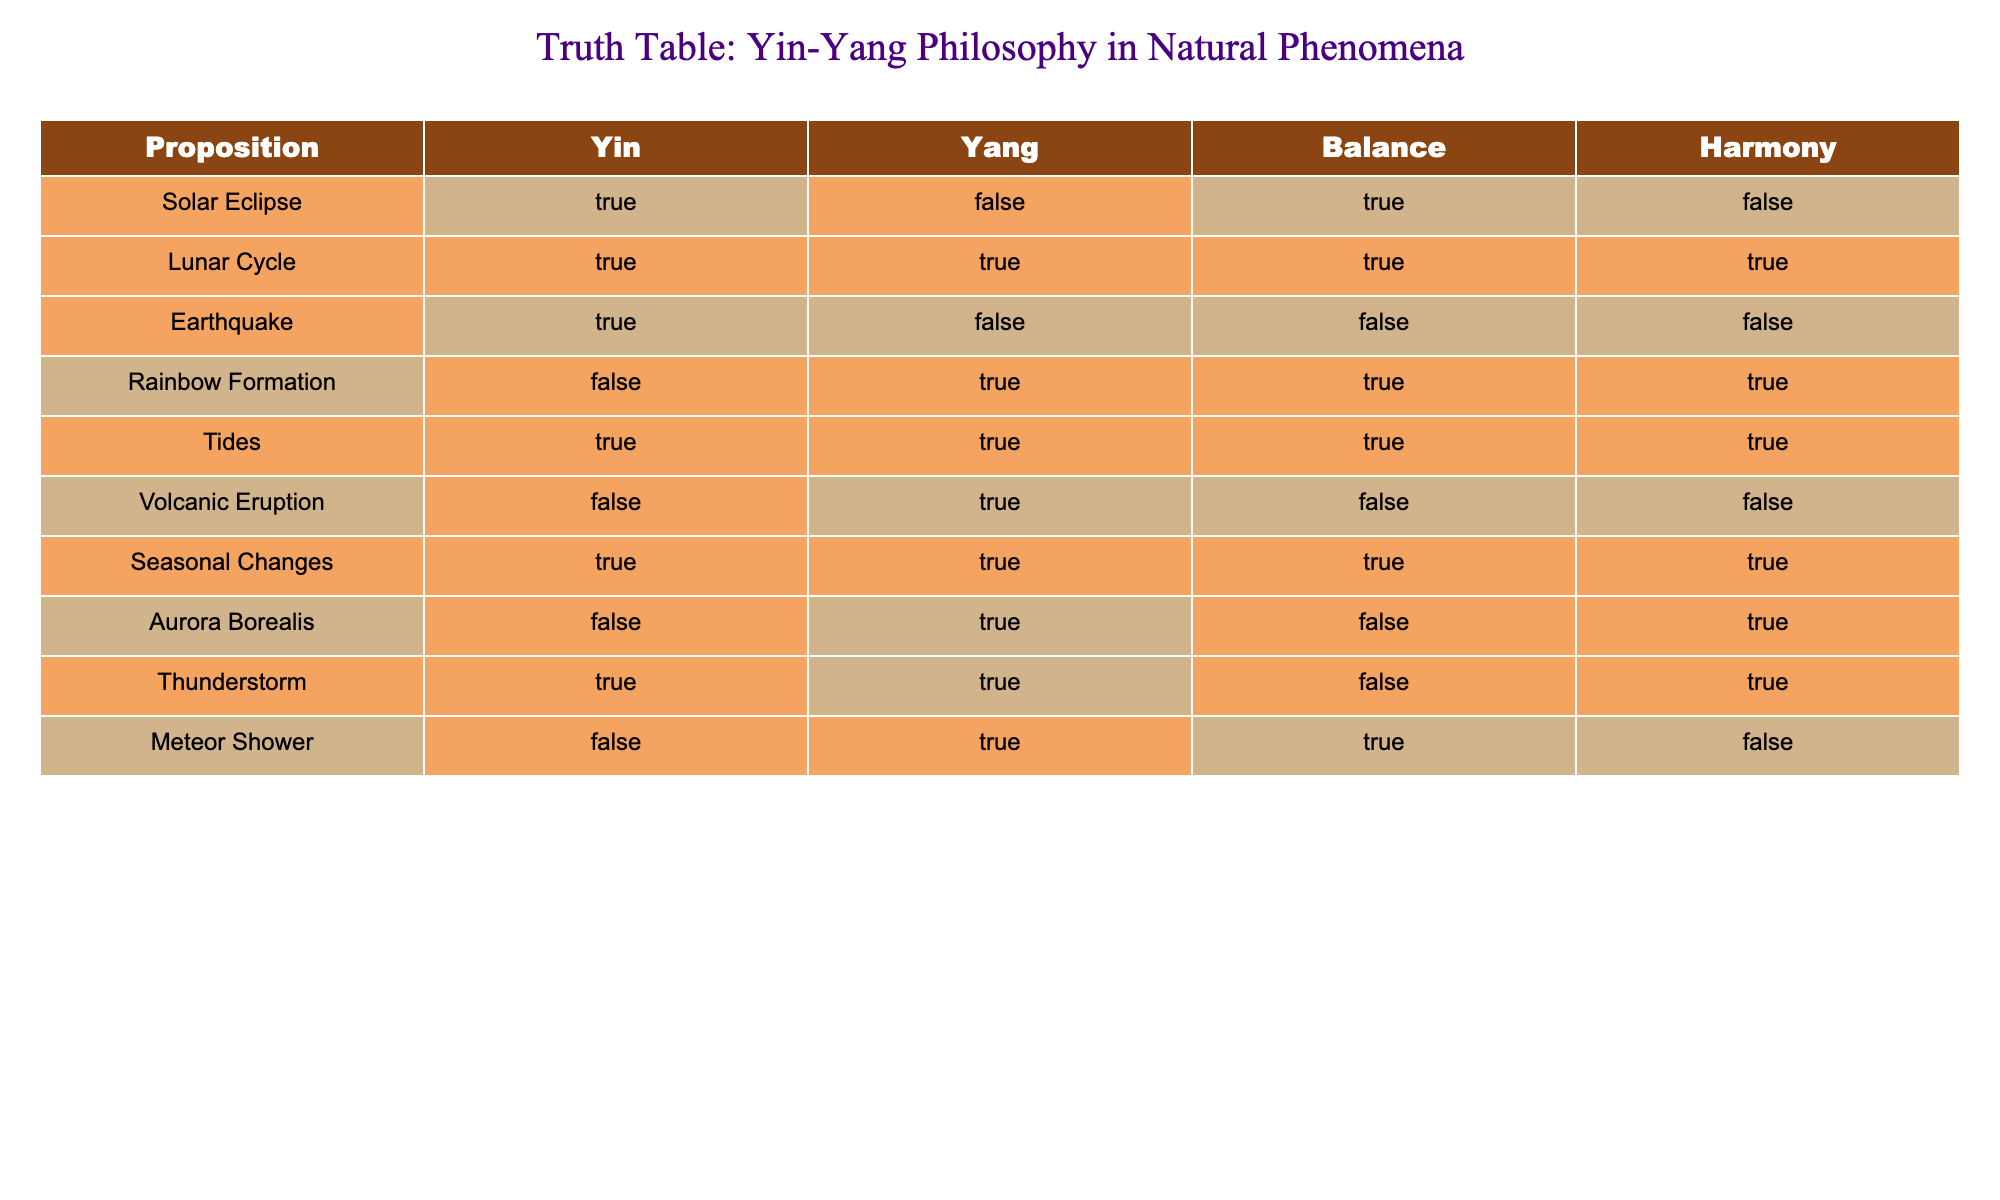What natural phenomenon is associated with Yin but not Yang? Looking at the table, the only phenomenon that has TRUE for Yin and FALSE for Yang is "Solar Eclipse."
Answer: Solar Eclipse How many phenomena have both Yin and Yang as TRUE? The phenomena that have both Yin and Yang as TRUE are the "Lunar Cycle," "Tides," and "Seasonal Changes." There are three such instances.
Answer: 3 Is a Rainbow Formation characterized by Harmony? In the table, "Rainbow Formation" has a TRUE value for Harmony. This indicates that it is indeed characterized by Harmony.
Answer: Yes Which phenomena indicate balance without harmony? The only phenomenon that has TRUE for Balance but FALSE for Harmony is "Tides."
Answer: Tides What is the total number of phenomena that exhibit Yin? Counting the TRUE values under the Yin column: Solar Eclipse, Lunar Cycle, Earthquake, Tides, Seasonal Changes, and Thunderstorm, we find six instances.
Answer: 6 Is there any phenomenon that has TRUE for Yang and FALSE for Balance? Analyzing the table, "Volcanic Eruption" has TRUE for Yang and FALSE for Balance, making it an exception.
Answer: Yes Which phenomenon has no Yin attributes? The phenomenon that has FALSE for Yin is "Rainbow Formation," "Volcanic Eruption," and "Aurora Borealis." "Rainbow Formation" is the only one characterized by Harmony.
Answer: Rainbow Formation How many phenomena are both balanced and harmonious? By examining the Balance and Harmony columns, the phenomena that have both TRUE are "Lunar Cycle," "Rainbow Formation," "Tides," and "Seasonal Changes." This results in four such phenomena.
Answer: 4 